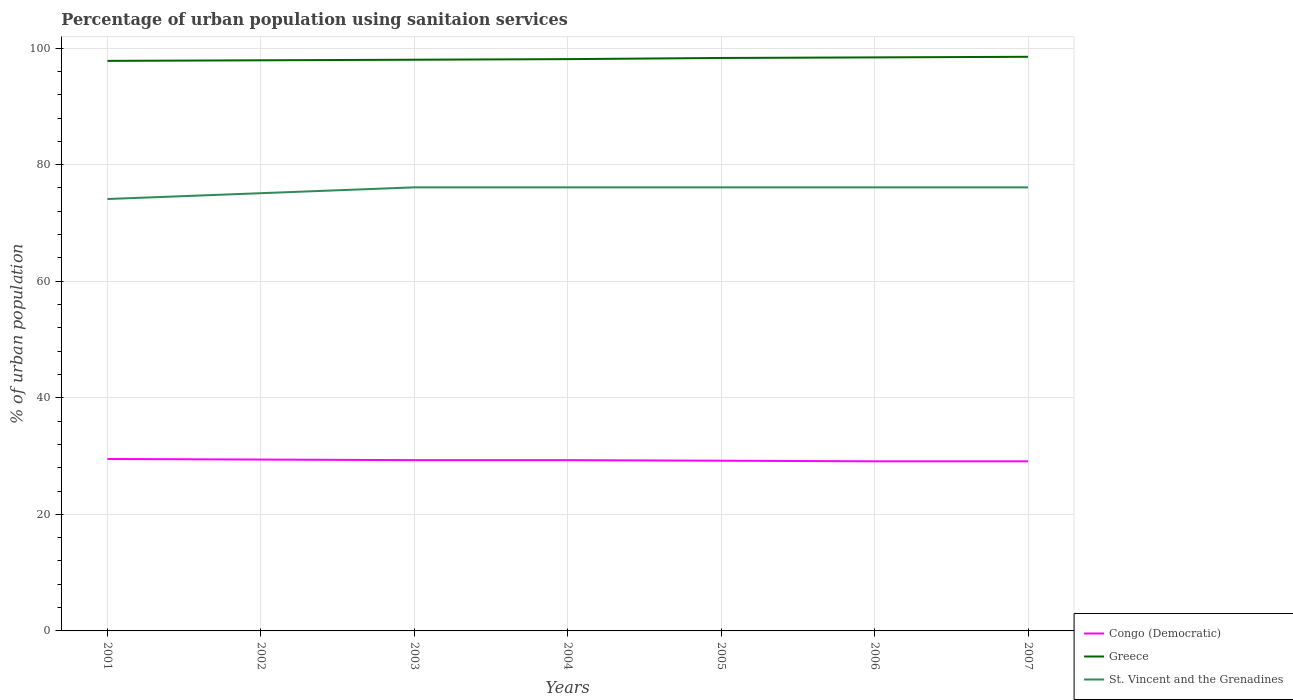How many different coloured lines are there?
Give a very brief answer. 3. Is the number of lines equal to the number of legend labels?
Provide a short and direct response. Yes. Across all years, what is the maximum percentage of urban population using sanitaion services in Greece?
Give a very brief answer. 97.8. In which year was the percentage of urban population using sanitaion services in St. Vincent and the Grenadines maximum?
Your answer should be compact. 2001. What is the difference between the highest and the second highest percentage of urban population using sanitaion services in St. Vincent and the Grenadines?
Ensure brevity in your answer.  2. What is the difference between the highest and the lowest percentage of urban population using sanitaion services in Congo (Democratic)?
Provide a short and direct response. 4. How many years are there in the graph?
Ensure brevity in your answer.  7. What is the difference between two consecutive major ticks on the Y-axis?
Ensure brevity in your answer.  20. Are the values on the major ticks of Y-axis written in scientific E-notation?
Give a very brief answer. No. How many legend labels are there?
Your response must be concise. 3. What is the title of the graph?
Ensure brevity in your answer.  Percentage of urban population using sanitaion services. Does "World" appear as one of the legend labels in the graph?
Your answer should be very brief. No. What is the label or title of the Y-axis?
Your response must be concise. % of urban population. What is the % of urban population in Congo (Democratic) in 2001?
Keep it short and to the point. 29.5. What is the % of urban population in Greece in 2001?
Provide a short and direct response. 97.8. What is the % of urban population in St. Vincent and the Grenadines in 2001?
Make the answer very short. 74.1. What is the % of urban population in Congo (Democratic) in 2002?
Keep it short and to the point. 29.4. What is the % of urban population of Greece in 2002?
Offer a very short reply. 97.9. What is the % of urban population in St. Vincent and the Grenadines in 2002?
Ensure brevity in your answer.  75.1. What is the % of urban population in Congo (Democratic) in 2003?
Give a very brief answer. 29.3. What is the % of urban population in St. Vincent and the Grenadines in 2003?
Your response must be concise. 76.1. What is the % of urban population of Congo (Democratic) in 2004?
Ensure brevity in your answer.  29.3. What is the % of urban population of Greece in 2004?
Give a very brief answer. 98.1. What is the % of urban population in St. Vincent and the Grenadines in 2004?
Your answer should be very brief. 76.1. What is the % of urban population in Congo (Democratic) in 2005?
Your response must be concise. 29.2. What is the % of urban population in Greece in 2005?
Your answer should be compact. 98.3. What is the % of urban population in St. Vincent and the Grenadines in 2005?
Make the answer very short. 76.1. What is the % of urban population of Congo (Democratic) in 2006?
Offer a terse response. 29.1. What is the % of urban population in Greece in 2006?
Your answer should be compact. 98.4. What is the % of urban population of St. Vincent and the Grenadines in 2006?
Make the answer very short. 76.1. What is the % of urban population in Congo (Democratic) in 2007?
Provide a short and direct response. 29.1. What is the % of urban population in Greece in 2007?
Your answer should be compact. 98.5. What is the % of urban population of St. Vincent and the Grenadines in 2007?
Make the answer very short. 76.1. Across all years, what is the maximum % of urban population of Congo (Democratic)?
Offer a very short reply. 29.5. Across all years, what is the maximum % of urban population in Greece?
Keep it short and to the point. 98.5. Across all years, what is the maximum % of urban population in St. Vincent and the Grenadines?
Ensure brevity in your answer.  76.1. Across all years, what is the minimum % of urban population of Congo (Democratic)?
Your response must be concise. 29.1. Across all years, what is the minimum % of urban population of Greece?
Your response must be concise. 97.8. Across all years, what is the minimum % of urban population in St. Vincent and the Grenadines?
Provide a succinct answer. 74.1. What is the total % of urban population of Congo (Democratic) in the graph?
Your answer should be very brief. 204.9. What is the total % of urban population in Greece in the graph?
Offer a terse response. 687. What is the total % of urban population of St. Vincent and the Grenadines in the graph?
Offer a terse response. 529.7. What is the difference between the % of urban population of Greece in 2001 and that in 2002?
Offer a very short reply. -0.1. What is the difference between the % of urban population in Congo (Democratic) in 2001 and that in 2004?
Make the answer very short. 0.2. What is the difference between the % of urban population of Greece in 2001 and that in 2004?
Give a very brief answer. -0.3. What is the difference between the % of urban population in St. Vincent and the Grenadines in 2001 and that in 2004?
Your answer should be compact. -2. What is the difference between the % of urban population of Congo (Democratic) in 2001 and that in 2005?
Offer a terse response. 0.3. What is the difference between the % of urban population in St. Vincent and the Grenadines in 2001 and that in 2005?
Offer a terse response. -2. What is the difference between the % of urban population of Greece in 2001 and that in 2006?
Ensure brevity in your answer.  -0.6. What is the difference between the % of urban population in Greece in 2002 and that in 2003?
Keep it short and to the point. -0.1. What is the difference between the % of urban population of St. Vincent and the Grenadines in 2002 and that in 2004?
Your answer should be very brief. -1. What is the difference between the % of urban population in St. Vincent and the Grenadines in 2002 and that in 2005?
Your response must be concise. -1. What is the difference between the % of urban population in Congo (Democratic) in 2002 and that in 2006?
Give a very brief answer. 0.3. What is the difference between the % of urban population in Congo (Democratic) in 2002 and that in 2007?
Give a very brief answer. 0.3. What is the difference between the % of urban population in Greece in 2003 and that in 2004?
Offer a very short reply. -0.1. What is the difference between the % of urban population in Congo (Democratic) in 2003 and that in 2005?
Your response must be concise. 0.1. What is the difference between the % of urban population in Greece in 2003 and that in 2005?
Give a very brief answer. -0.3. What is the difference between the % of urban population of Congo (Democratic) in 2003 and that in 2006?
Provide a short and direct response. 0.2. What is the difference between the % of urban population of St. Vincent and the Grenadines in 2003 and that in 2006?
Provide a short and direct response. 0. What is the difference between the % of urban population of St. Vincent and the Grenadines in 2003 and that in 2007?
Your answer should be very brief. 0. What is the difference between the % of urban population of Congo (Democratic) in 2004 and that in 2007?
Ensure brevity in your answer.  0.2. What is the difference between the % of urban population in Greece in 2004 and that in 2007?
Keep it short and to the point. -0.4. What is the difference between the % of urban population in St. Vincent and the Grenadines in 2004 and that in 2007?
Keep it short and to the point. 0. What is the difference between the % of urban population of Congo (Democratic) in 2005 and that in 2006?
Provide a short and direct response. 0.1. What is the difference between the % of urban population in Greece in 2005 and that in 2006?
Offer a very short reply. -0.1. What is the difference between the % of urban population in Congo (Democratic) in 2005 and that in 2007?
Your response must be concise. 0.1. What is the difference between the % of urban population of St. Vincent and the Grenadines in 2006 and that in 2007?
Offer a very short reply. 0. What is the difference between the % of urban population of Congo (Democratic) in 2001 and the % of urban population of Greece in 2002?
Offer a terse response. -68.4. What is the difference between the % of urban population in Congo (Democratic) in 2001 and the % of urban population in St. Vincent and the Grenadines in 2002?
Provide a short and direct response. -45.6. What is the difference between the % of urban population of Greece in 2001 and the % of urban population of St. Vincent and the Grenadines in 2002?
Ensure brevity in your answer.  22.7. What is the difference between the % of urban population in Congo (Democratic) in 2001 and the % of urban population in Greece in 2003?
Your answer should be compact. -68.5. What is the difference between the % of urban population of Congo (Democratic) in 2001 and the % of urban population of St. Vincent and the Grenadines in 2003?
Your response must be concise. -46.6. What is the difference between the % of urban population of Greece in 2001 and the % of urban population of St. Vincent and the Grenadines in 2003?
Keep it short and to the point. 21.7. What is the difference between the % of urban population of Congo (Democratic) in 2001 and the % of urban population of Greece in 2004?
Keep it short and to the point. -68.6. What is the difference between the % of urban population of Congo (Democratic) in 2001 and the % of urban population of St. Vincent and the Grenadines in 2004?
Make the answer very short. -46.6. What is the difference between the % of urban population of Greece in 2001 and the % of urban population of St. Vincent and the Grenadines in 2004?
Make the answer very short. 21.7. What is the difference between the % of urban population of Congo (Democratic) in 2001 and the % of urban population of Greece in 2005?
Your response must be concise. -68.8. What is the difference between the % of urban population in Congo (Democratic) in 2001 and the % of urban population in St. Vincent and the Grenadines in 2005?
Your answer should be compact. -46.6. What is the difference between the % of urban population in Greece in 2001 and the % of urban population in St. Vincent and the Grenadines in 2005?
Offer a terse response. 21.7. What is the difference between the % of urban population in Congo (Democratic) in 2001 and the % of urban population in Greece in 2006?
Keep it short and to the point. -68.9. What is the difference between the % of urban population of Congo (Democratic) in 2001 and the % of urban population of St. Vincent and the Grenadines in 2006?
Provide a succinct answer. -46.6. What is the difference between the % of urban population of Greece in 2001 and the % of urban population of St. Vincent and the Grenadines in 2006?
Give a very brief answer. 21.7. What is the difference between the % of urban population of Congo (Democratic) in 2001 and the % of urban population of Greece in 2007?
Provide a succinct answer. -69. What is the difference between the % of urban population of Congo (Democratic) in 2001 and the % of urban population of St. Vincent and the Grenadines in 2007?
Ensure brevity in your answer.  -46.6. What is the difference between the % of urban population in Greece in 2001 and the % of urban population in St. Vincent and the Grenadines in 2007?
Keep it short and to the point. 21.7. What is the difference between the % of urban population of Congo (Democratic) in 2002 and the % of urban population of Greece in 2003?
Offer a terse response. -68.6. What is the difference between the % of urban population in Congo (Democratic) in 2002 and the % of urban population in St. Vincent and the Grenadines in 2003?
Offer a very short reply. -46.7. What is the difference between the % of urban population of Greece in 2002 and the % of urban population of St. Vincent and the Grenadines in 2003?
Keep it short and to the point. 21.8. What is the difference between the % of urban population in Congo (Democratic) in 2002 and the % of urban population in Greece in 2004?
Offer a very short reply. -68.7. What is the difference between the % of urban population in Congo (Democratic) in 2002 and the % of urban population in St. Vincent and the Grenadines in 2004?
Ensure brevity in your answer.  -46.7. What is the difference between the % of urban population in Greece in 2002 and the % of urban population in St. Vincent and the Grenadines in 2004?
Your answer should be compact. 21.8. What is the difference between the % of urban population in Congo (Democratic) in 2002 and the % of urban population in Greece in 2005?
Offer a terse response. -68.9. What is the difference between the % of urban population in Congo (Democratic) in 2002 and the % of urban population in St. Vincent and the Grenadines in 2005?
Give a very brief answer. -46.7. What is the difference between the % of urban population in Greece in 2002 and the % of urban population in St. Vincent and the Grenadines in 2005?
Make the answer very short. 21.8. What is the difference between the % of urban population of Congo (Democratic) in 2002 and the % of urban population of Greece in 2006?
Provide a short and direct response. -69. What is the difference between the % of urban population of Congo (Democratic) in 2002 and the % of urban population of St. Vincent and the Grenadines in 2006?
Your answer should be very brief. -46.7. What is the difference between the % of urban population of Greece in 2002 and the % of urban population of St. Vincent and the Grenadines in 2006?
Your answer should be compact. 21.8. What is the difference between the % of urban population of Congo (Democratic) in 2002 and the % of urban population of Greece in 2007?
Your answer should be compact. -69.1. What is the difference between the % of urban population in Congo (Democratic) in 2002 and the % of urban population in St. Vincent and the Grenadines in 2007?
Provide a short and direct response. -46.7. What is the difference between the % of urban population of Greece in 2002 and the % of urban population of St. Vincent and the Grenadines in 2007?
Keep it short and to the point. 21.8. What is the difference between the % of urban population in Congo (Democratic) in 2003 and the % of urban population in Greece in 2004?
Ensure brevity in your answer.  -68.8. What is the difference between the % of urban population in Congo (Democratic) in 2003 and the % of urban population in St. Vincent and the Grenadines in 2004?
Offer a very short reply. -46.8. What is the difference between the % of urban population of Greece in 2003 and the % of urban population of St. Vincent and the Grenadines in 2004?
Offer a terse response. 21.9. What is the difference between the % of urban population in Congo (Democratic) in 2003 and the % of urban population in Greece in 2005?
Make the answer very short. -69. What is the difference between the % of urban population in Congo (Democratic) in 2003 and the % of urban population in St. Vincent and the Grenadines in 2005?
Give a very brief answer. -46.8. What is the difference between the % of urban population of Greece in 2003 and the % of urban population of St. Vincent and the Grenadines in 2005?
Make the answer very short. 21.9. What is the difference between the % of urban population in Congo (Democratic) in 2003 and the % of urban population in Greece in 2006?
Provide a short and direct response. -69.1. What is the difference between the % of urban population in Congo (Democratic) in 2003 and the % of urban population in St. Vincent and the Grenadines in 2006?
Your response must be concise. -46.8. What is the difference between the % of urban population of Greece in 2003 and the % of urban population of St. Vincent and the Grenadines in 2006?
Your response must be concise. 21.9. What is the difference between the % of urban population in Congo (Democratic) in 2003 and the % of urban population in Greece in 2007?
Keep it short and to the point. -69.2. What is the difference between the % of urban population of Congo (Democratic) in 2003 and the % of urban population of St. Vincent and the Grenadines in 2007?
Offer a very short reply. -46.8. What is the difference between the % of urban population in Greece in 2003 and the % of urban population in St. Vincent and the Grenadines in 2007?
Your answer should be very brief. 21.9. What is the difference between the % of urban population in Congo (Democratic) in 2004 and the % of urban population in Greece in 2005?
Make the answer very short. -69. What is the difference between the % of urban population in Congo (Democratic) in 2004 and the % of urban population in St. Vincent and the Grenadines in 2005?
Your answer should be compact. -46.8. What is the difference between the % of urban population of Greece in 2004 and the % of urban population of St. Vincent and the Grenadines in 2005?
Offer a very short reply. 22. What is the difference between the % of urban population of Congo (Democratic) in 2004 and the % of urban population of Greece in 2006?
Your response must be concise. -69.1. What is the difference between the % of urban population in Congo (Democratic) in 2004 and the % of urban population in St. Vincent and the Grenadines in 2006?
Ensure brevity in your answer.  -46.8. What is the difference between the % of urban population of Congo (Democratic) in 2004 and the % of urban population of Greece in 2007?
Your response must be concise. -69.2. What is the difference between the % of urban population of Congo (Democratic) in 2004 and the % of urban population of St. Vincent and the Grenadines in 2007?
Your response must be concise. -46.8. What is the difference between the % of urban population of Greece in 2004 and the % of urban population of St. Vincent and the Grenadines in 2007?
Provide a succinct answer. 22. What is the difference between the % of urban population of Congo (Democratic) in 2005 and the % of urban population of Greece in 2006?
Provide a short and direct response. -69.2. What is the difference between the % of urban population in Congo (Democratic) in 2005 and the % of urban population in St. Vincent and the Grenadines in 2006?
Your answer should be compact. -46.9. What is the difference between the % of urban population of Greece in 2005 and the % of urban population of St. Vincent and the Grenadines in 2006?
Make the answer very short. 22.2. What is the difference between the % of urban population of Congo (Democratic) in 2005 and the % of urban population of Greece in 2007?
Offer a very short reply. -69.3. What is the difference between the % of urban population of Congo (Democratic) in 2005 and the % of urban population of St. Vincent and the Grenadines in 2007?
Your answer should be very brief. -46.9. What is the difference between the % of urban population of Congo (Democratic) in 2006 and the % of urban population of Greece in 2007?
Offer a terse response. -69.4. What is the difference between the % of urban population of Congo (Democratic) in 2006 and the % of urban population of St. Vincent and the Grenadines in 2007?
Provide a short and direct response. -47. What is the difference between the % of urban population in Greece in 2006 and the % of urban population in St. Vincent and the Grenadines in 2007?
Offer a very short reply. 22.3. What is the average % of urban population in Congo (Democratic) per year?
Give a very brief answer. 29.27. What is the average % of urban population in Greece per year?
Give a very brief answer. 98.14. What is the average % of urban population in St. Vincent and the Grenadines per year?
Make the answer very short. 75.67. In the year 2001, what is the difference between the % of urban population in Congo (Democratic) and % of urban population in Greece?
Make the answer very short. -68.3. In the year 2001, what is the difference between the % of urban population of Congo (Democratic) and % of urban population of St. Vincent and the Grenadines?
Ensure brevity in your answer.  -44.6. In the year 2001, what is the difference between the % of urban population of Greece and % of urban population of St. Vincent and the Grenadines?
Give a very brief answer. 23.7. In the year 2002, what is the difference between the % of urban population of Congo (Democratic) and % of urban population of Greece?
Your response must be concise. -68.5. In the year 2002, what is the difference between the % of urban population in Congo (Democratic) and % of urban population in St. Vincent and the Grenadines?
Your answer should be very brief. -45.7. In the year 2002, what is the difference between the % of urban population of Greece and % of urban population of St. Vincent and the Grenadines?
Your response must be concise. 22.8. In the year 2003, what is the difference between the % of urban population in Congo (Democratic) and % of urban population in Greece?
Your answer should be compact. -68.7. In the year 2003, what is the difference between the % of urban population of Congo (Democratic) and % of urban population of St. Vincent and the Grenadines?
Your response must be concise. -46.8. In the year 2003, what is the difference between the % of urban population in Greece and % of urban population in St. Vincent and the Grenadines?
Provide a short and direct response. 21.9. In the year 2004, what is the difference between the % of urban population in Congo (Democratic) and % of urban population in Greece?
Ensure brevity in your answer.  -68.8. In the year 2004, what is the difference between the % of urban population of Congo (Democratic) and % of urban population of St. Vincent and the Grenadines?
Your answer should be very brief. -46.8. In the year 2005, what is the difference between the % of urban population of Congo (Democratic) and % of urban population of Greece?
Give a very brief answer. -69.1. In the year 2005, what is the difference between the % of urban population in Congo (Democratic) and % of urban population in St. Vincent and the Grenadines?
Your response must be concise. -46.9. In the year 2005, what is the difference between the % of urban population in Greece and % of urban population in St. Vincent and the Grenadines?
Make the answer very short. 22.2. In the year 2006, what is the difference between the % of urban population of Congo (Democratic) and % of urban population of Greece?
Your answer should be compact. -69.3. In the year 2006, what is the difference between the % of urban population in Congo (Democratic) and % of urban population in St. Vincent and the Grenadines?
Your answer should be compact. -47. In the year 2006, what is the difference between the % of urban population of Greece and % of urban population of St. Vincent and the Grenadines?
Keep it short and to the point. 22.3. In the year 2007, what is the difference between the % of urban population in Congo (Democratic) and % of urban population in Greece?
Offer a terse response. -69.4. In the year 2007, what is the difference between the % of urban population of Congo (Democratic) and % of urban population of St. Vincent and the Grenadines?
Provide a short and direct response. -47. In the year 2007, what is the difference between the % of urban population of Greece and % of urban population of St. Vincent and the Grenadines?
Keep it short and to the point. 22.4. What is the ratio of the % of urban population in St. Vincent and the Grenadines in 2001 to that in 2002?
Provide a short and direct response. 0.99. What is the ratio of the % of urban population of Congo (Democratic) in 2001 to that in 2003?
Offer a very short reply. 1.01. What is the ratio of the % of urban population in Greece in 2001 to that in 2003?
Your answer should be very brief. 1. What is the ratio of the % of urban population in St. Vincent and the Grenadines in 2001 to that in 2003?
Offer a very short reply. 0.97. What is the ratio of the % of urban population in Congo (Democratic) in 2001 to that in 2004?
Offer a terse response. 1.01. What is the ratio of the % of urban population of St. Vincent and the Grenadines in 2001 to that in 2004?
Give a very brief answer. 0.97. What is the ratio of the % of urban population of Congo (Democratic) in 2001 to that in 2005?
Your response must be concise. 1.01. What is the ratio of the % of urban population in Greece in 2001 to that in 2005?
Your answer should be very brief. 0.99. What is the ratio of the % of urban population in St. Vincent and the Grenadines in 2001 to that in 2005?
Your response must be concise. 0.97. What is the ratio of the % of urban population of Congo (Democratic) in 2001 to that in 2006?
Make the answer very short. 1.01. What is the ratio of the % of urban population in Greece in 2001 to that in 2006?
Your answer should be very brief. 0.99. What is the ratio of the % of urban population of St. Vincent and the Grenadines in 2001 to that in 2006?
Provide a succinct answer. 0.97. What is the ratio of the % of urban population of Congo (Democratic) in 2001 to that in 2007?
Your answer should be very brief. 1.01. What is the ratio of the % of urban population of St. Vincent and the Grenadines in 2001 to that in 2007?
Provide a succinct answer. 0.97. What is the ratio of the % of urban population of St. Vincent and the Grenadines in 2002 to that in 2003?
Make the answer very short. 0.99. What is the ratio of the % of urban population in Congo (Democratic) in 2002 to that in 2004?
Ensure brevity in your answer.  1. What is the ratio of the % of urban population of St. Vincent and the Grenadines in 2002 to that in 2004?
Your answer should be very brief. 0.99. What is the ratio of the % of urban population in Congo (Democratic) in 2002 to that in 2005?
Provide a succinct answer. 1.01. What is the ratio of the % of urban population in Greece in 2002 to that in 2005?
Your answer should be compact. 1. What is the ratio of the % of urban population in St. Vincent and the Grenadines in 2002 to that in 2005?
Ensure brevity in your answer.  0.99. What is the ratio of the % of urban population of Congo (Democratic) in 2002 to that in 2006?
Keep it short and to the point. 1.01. What is the ratio of the % of urban population in Greece in 2002 to that in 2006?
Your answer should be compact. 0.99. What is the ratio of the % of urban population in St. Vincent and the Grenadines in 2002 to that in 2006?
Make the answer very short. 0.99. What is the ratio of the % of urban population of Congo (Democratic) in 2002 to that in 2007?
Make the answer very short. 1.01. What is the ratio of the % of urban population in St. Vincent and the Grenadines in 2002 to that in 2007?
Give a very brief answer. 0.99. What is the ratio of the % of urban population of Congo (Democratic) in 2003 to that in 2004?
Your answer should be very brief. 1. What is the ratio of the % of urban population in Greece in 2003 to that in 2004?
Your answer should be compact. 1. What is the ratio of the % of urban population in Greece in 2003 to that in 2005?
Keep it short and to the point. 1. What is the ratio of the % of urban population in Congo (Democratic) in 2003 to that in 2006?
Provide a succinct answer. 1.01. What is the ratio of the % of urban population of Greece in 2003 to that in 2006?
Provide a succinct answer. 1. What is the ratio of the % of urban population of St. Vincent and the Grenadines in 2003 to that in 2006?
Provide a succinct answer. 1. What is the ratio of the % of urban population in Greece in 2003 to that in 2007?
Your answer should be very brief. 0.99. What is the ratio of the % of urban population of St. Vincent and the Grenadines in 2003 to that in 2007?
Provide a short and direct response. 1. What is the ratio of the % of urban population of Greece in 2004 to that in 2005?
Provide a short and direct response. 1. What is the ratio of the % of urban population in St. Vincent and the Grenadines in 2004 to that in 2006?
Offer a terse response. 1. What is the ratio of the % of urban population of Congo (Democratic) in 2004 to that in 2007?
Make the answer very short. 1.01. What is the ratio of the % of urban population in Greece in 2004 to that in 2007?
Provide a succinct answer. 1. What is the ratio of the % of urban population of Greece in 2005 to that in 2007?
Offer a terse response. 1. What is the ratio of the % of urban population of St. Vincent and the Grenadines in 2005 to that in 2007?
Your answer should be very brief. 1. What is the ratio of the % of urban population of Greece in 2006 to that in 2007?
Your answer should be very brief. 1. What is the difference between the highest and the second highest % of urban population in Greece?
Offer a very short reply. 0.1. What is the difference between the highest and the second highest % of urban population in St. Vincent and the Grenadines?
Keep it short and to the point. 0. What is the difference between the highest and the lowest % of urban population in Congo (Democratic)?
Keep it short and to the point. 0.4. What is the difference between the highest and the lowest % of urban population of Greece?
Your response must be concise. 0.7. What is the difference between the highest and the lowest % of urban population of St. Vincent and the Grenadines?
Give a very brief answer. 2. 